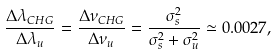Convert formula to latex. <formula><loc_0><loc_0><loc_500><loc_500>\frac { \Delta \lambda _ { C H G } } { \Delta \lambda _ { u } } = \frac { \Delta \nu _ { C H G } } { \Delta \nu _ { u } } = \frac { \sigma _ { s } ^ { 2 } } { \sigma _ { s } ^ { 2 } + \sigma _ { u } ^ { 2 } } \simeq 0 . 0 0 2 7 ,</formula> 